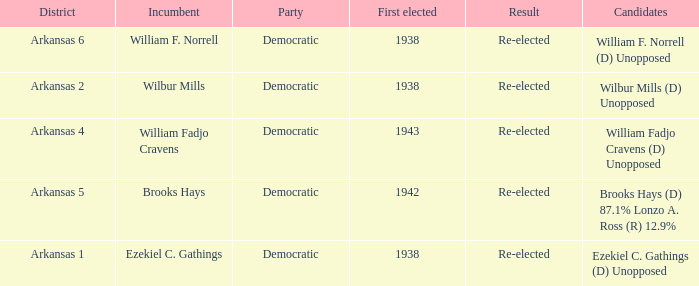What party did the incumbent from the Arkansas 5 district belong to?  Democratic. 